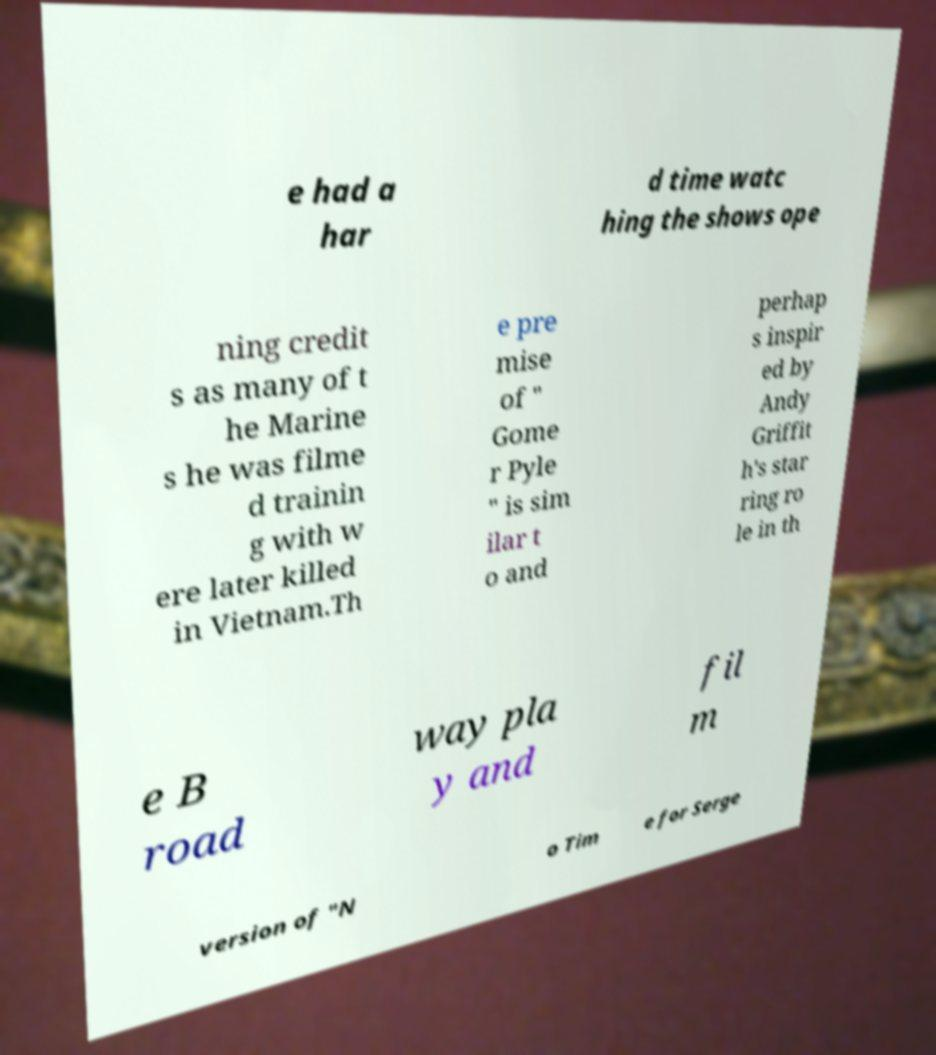Please read and relay the text visible in this image. What does it say? e had a har d time watc hing the shows ope ning credit s as many of t he Marine s he was filme d trainin g with w ere later killed in Vietnam.Th e pre mise of " Gome r Pyle " is sim ilar t o and perhap s inspir ed by Andy Griffit h's star ring ro le in th e B road way pla y and fil m version of "N o Tim e for Serge 